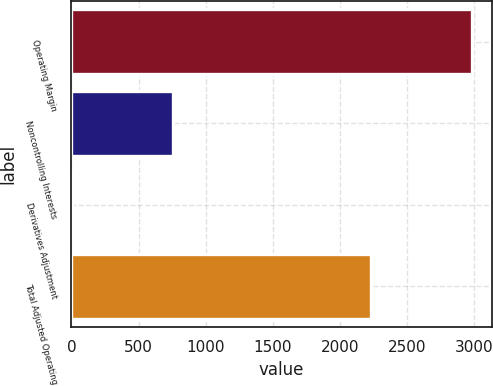Convert chart to OTSL. <chart><loc_0><loc_0><loc_500><loc_500><bar_chart><fcel>Operating Margin<fcel>Noncontrolling Interests<fcel>Derivatives Adjustment<fcel>Total Adjusted Operating<nl><fcel>2980<fcel>760<fcel>8<fcel>2228<nl></chart> 